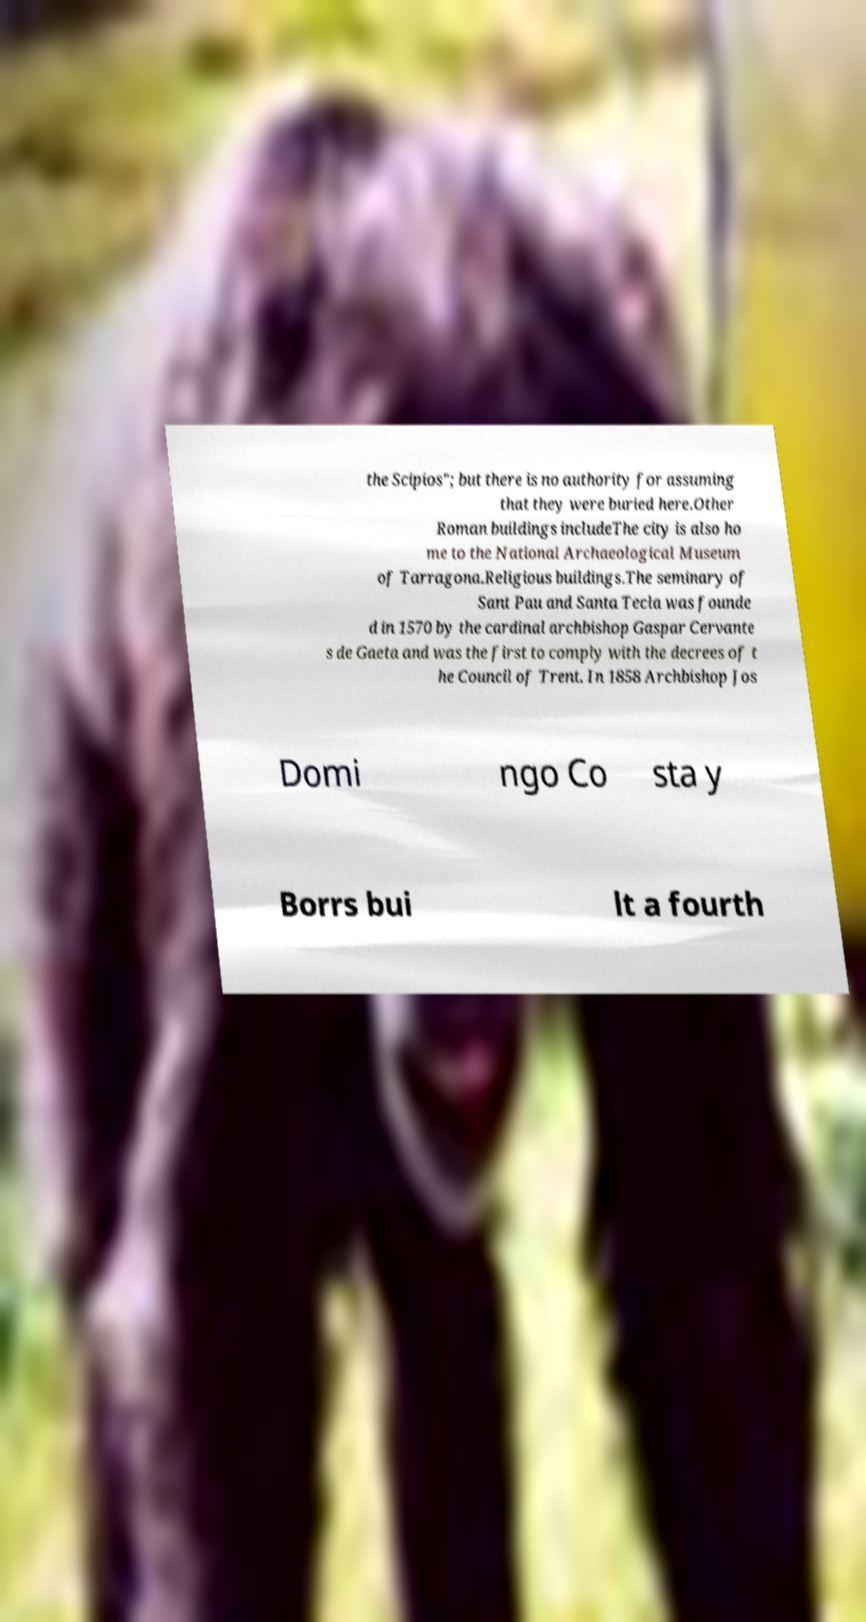Please identify and transcribe the text found in this image. the Scipios"; but there is no authority for assuming that they were buried here.Other Roman buildings includeThe city is also ho me to the National Archaeological Museum of Tarragona.Religious buildings.The seminary of Sant Pau and Santa Tecla was founde d in 1570 by the cardinal archbishop Gaspar Cervante s de Gaeta and was the first to comply with the decrees of t he Council of Trent. In 1858 Archbishop Jos Domi ngo Co sta y Borrs bui lt a fourth 